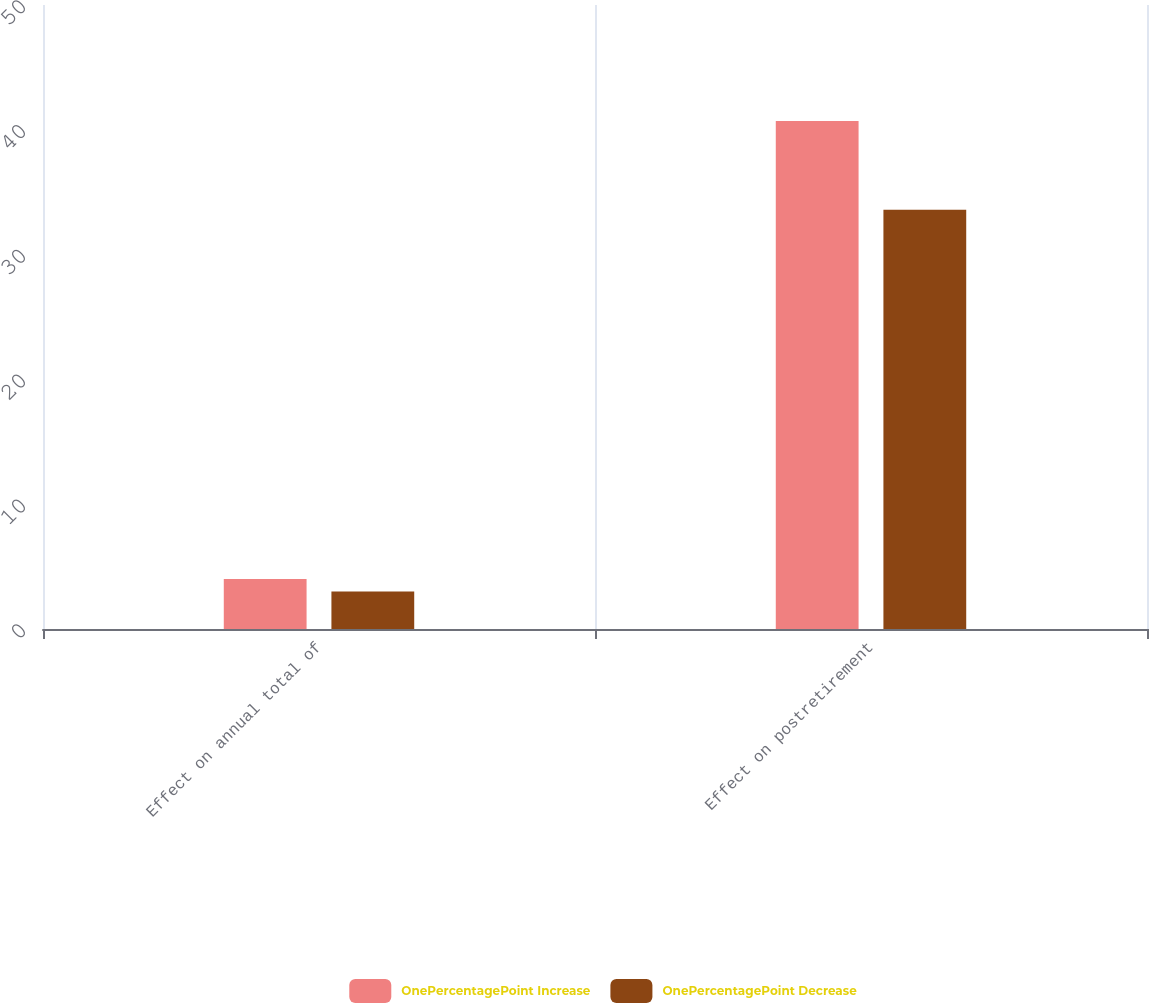Convert chart. <chart><loc_0><loc_0><loc_500><loc_500><stacked_bar_chart><ecel><fcel>Effect on annual total of<fcel>Effect on postretirement<nl><fcel>OnePercentagePoint Increase<fcel>4<fcel>40.7<nl><fcel>OnePercentagePoint Decrease<fcel>3<fcel>33.6<nl></chart> 